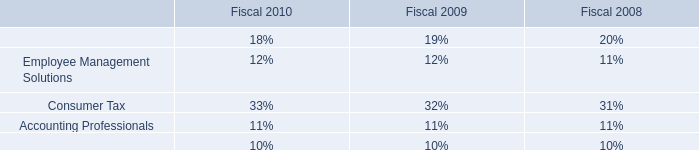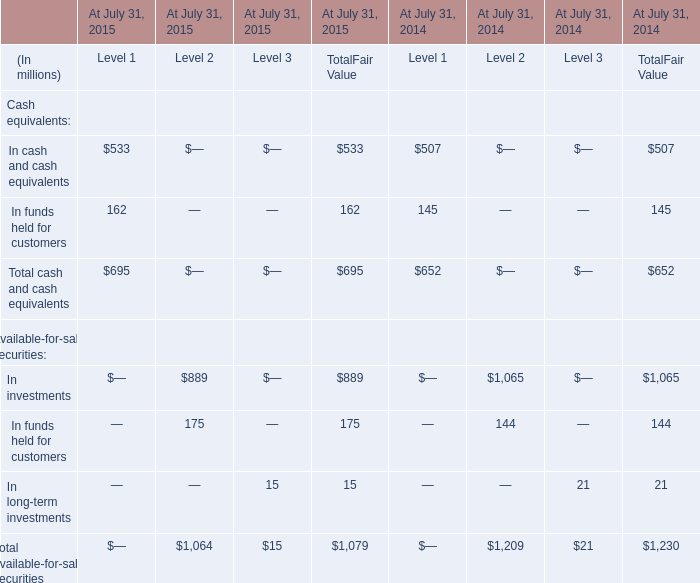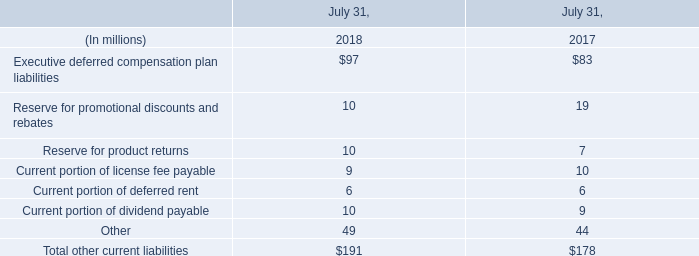What was the average of Total Fair Value of Total available-for-sale securities At July 31, 2015 and Total Fair Value of Total available-for-sale securities At July 31, 2014? (in million) 
Computations: ((1079 + 1230) / 2)
Answer: 1154.5. 